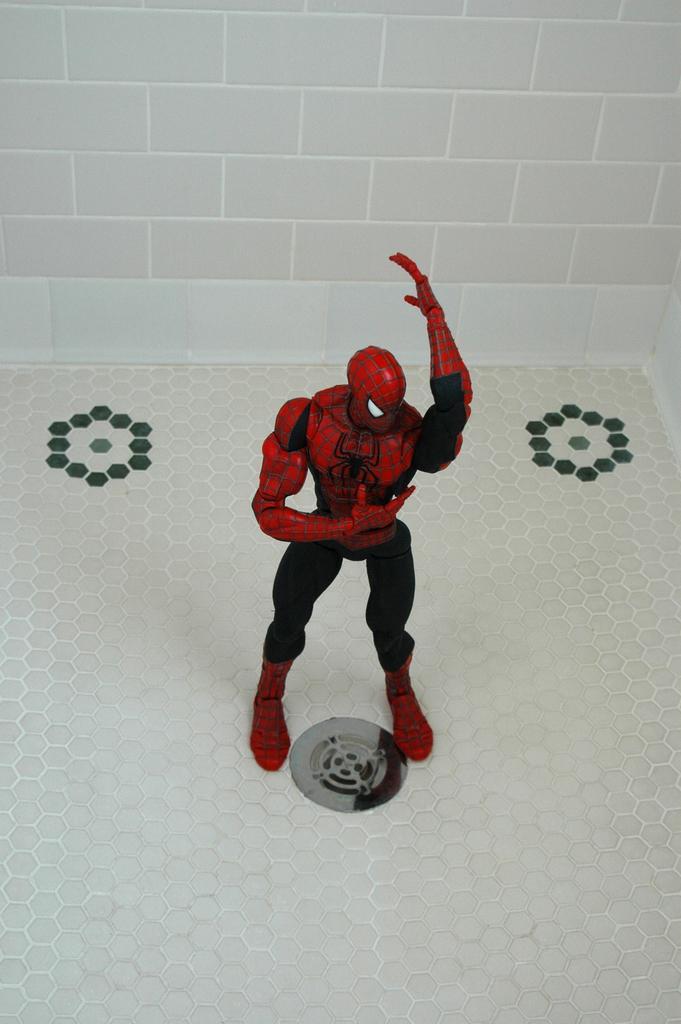Please provide a concise description of this image. In this image, we can see a red and black color spider man statue, in the background there is a white color brick wall. 